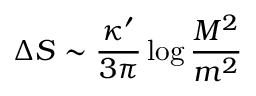<formula> <loc_0><loc_0><loc_500><loc_500>\Delta S \sim \frac { \kappa ^ { \prime } } { 3 \pi } \log { \frac { M ^ { 2 } } { m ^ { 2 } } } \,</formula> 